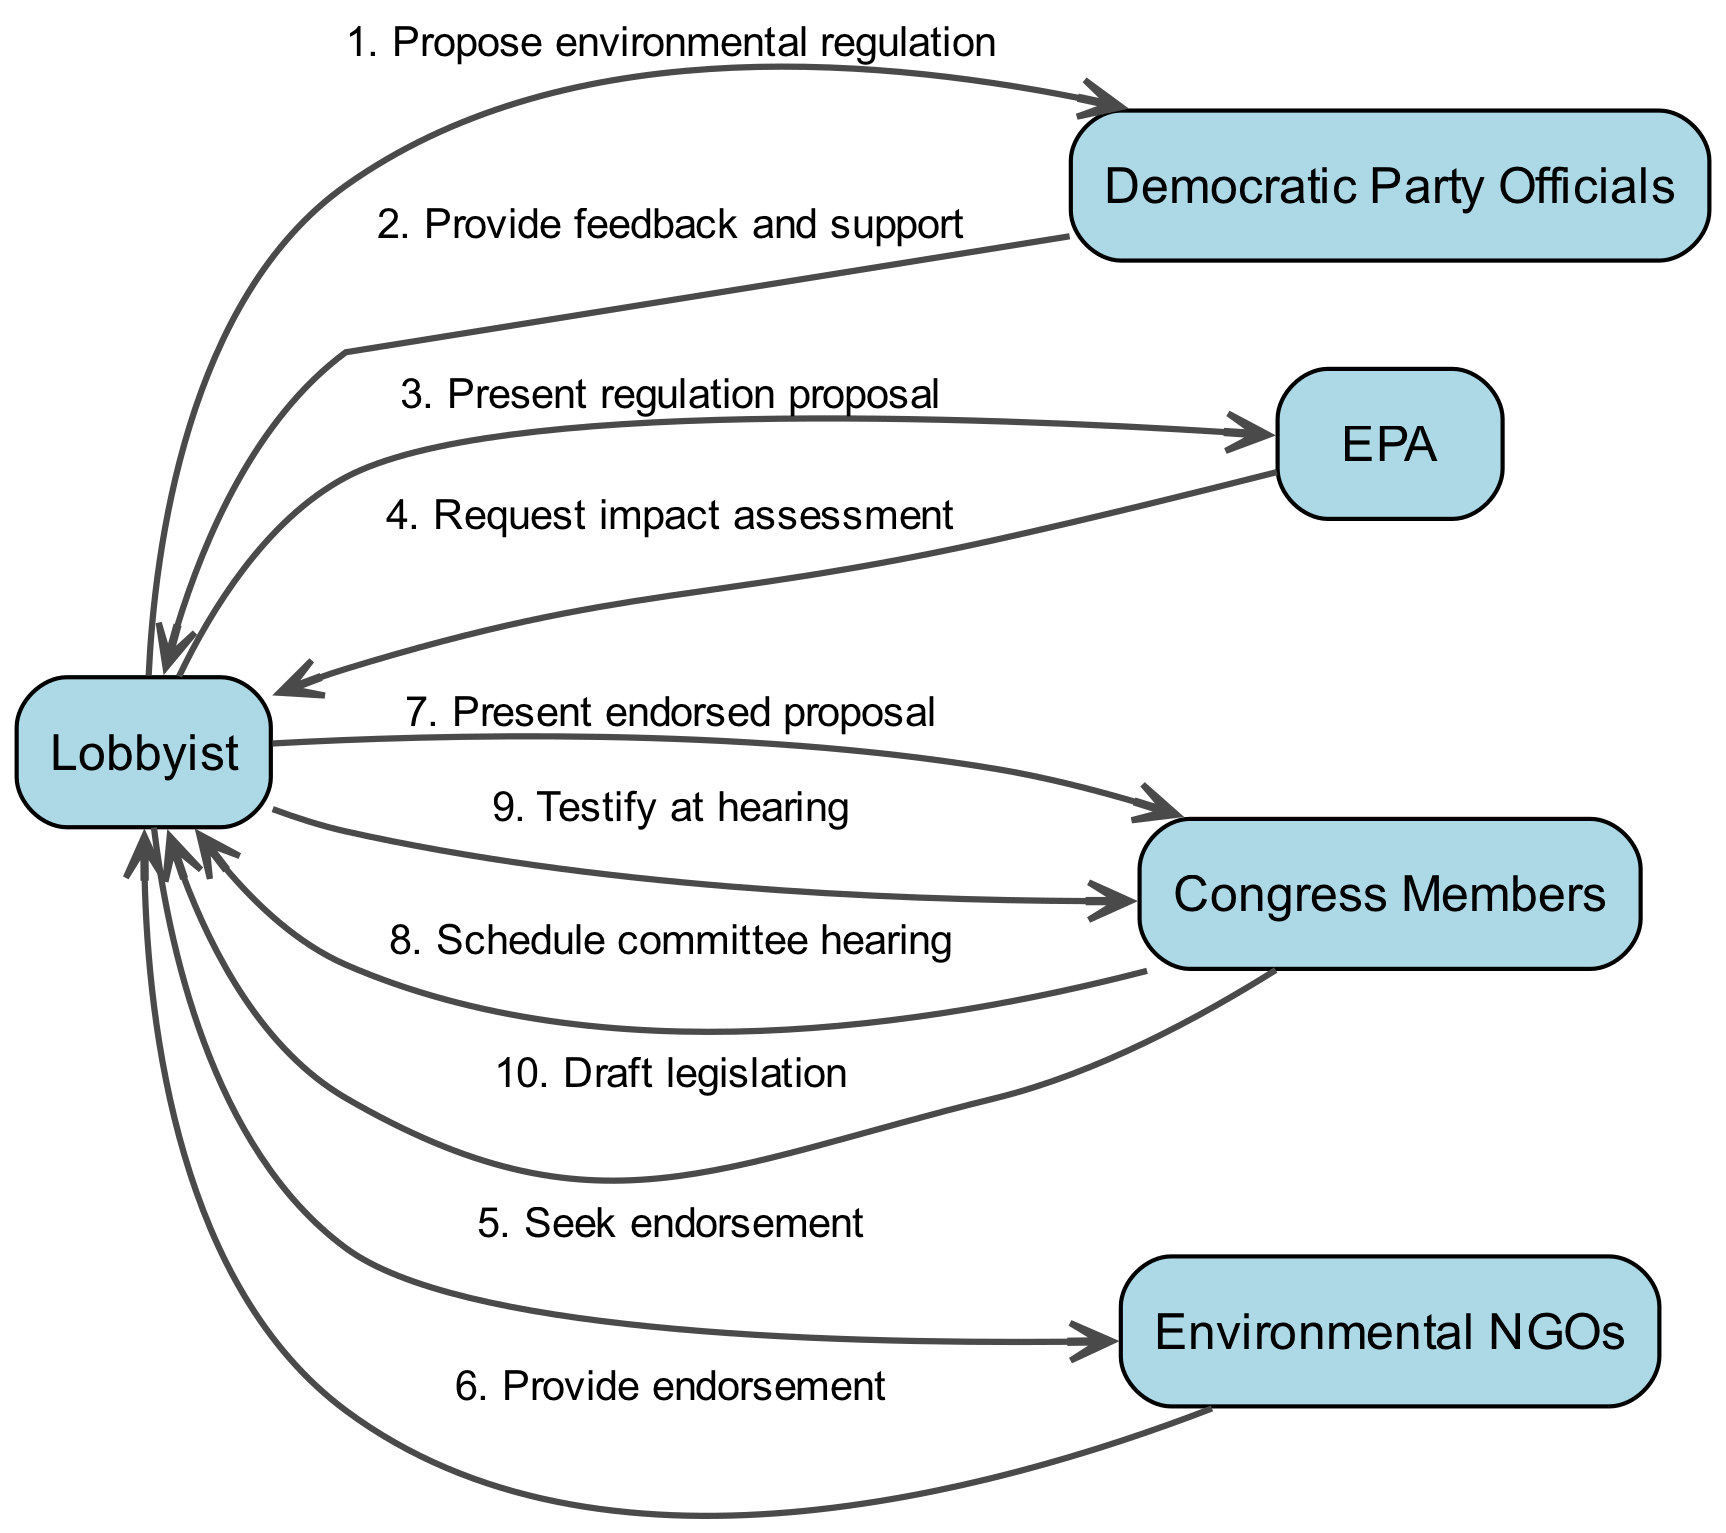What is the first action taken by the Lobbyist? The first action in the diagram is the Lobbyist proposing environmental regulation to the Democratic Party Officials. This is indicated as the first message in the sequence timeline.
Answer: Propose environmental regulation How many participants are involved in this lobbying campaign workflow? The diagram lists five distinct participants: Lobbyist, Democratic Party Officials, EPA, Congress Members, and Environmental NGOs. Counting each one gives a total of five.
Answer: Five Who provides feedback and support to the Lobbyist? According to the sequence, the Democratic Party Officials respond to the Lobbyist with feedback and support, as indicated in the second step of the sequence.
Answer: Democratic Party Officials What does the EPA request from the Lobbyist? In the flow of the diagram, after the Lobbyist presents the regulation proposal, the EPA replies by requesting an impact assessment as seen in the fourth sequence message.
Answer: Request impact assessment After receiving an endorsement, who does the Lobbyist present the proposal to next? Following the endorsement from Environmental NGOs, the Lobbyist then presents the endorsed proposal to Congress Members, as noted in the seventh action of the sequence.
Answer: Congress Members Which two entities are involved in drafting legislation? The final step in the diagram indicates that the Congress Members draft legislation, with the Lobbyist playing a role by testifying at the hearing, which is a precursor to drafting. The question specifies the Congress Members as the primary entity.
Answer: Congress Members What role do Environmental NGOs play in this workflow? Environmental NGOs are involved in providing endorsement for the regulation proposal after being approached by the Lobbyist in the fifth action of the sequence. This indicates their supportive role in the lobbying effort.
Answer: Provide endorsement Which action occurs directly after the Congress Members schedule a committee hearing? The sequence clearly shows that after Congress Members schedule a committee hearing, the Lobbyist's next action is to testify at that hearing. This shows a direct continuation of actions in the workflow.
Answer: Testify at hearing 